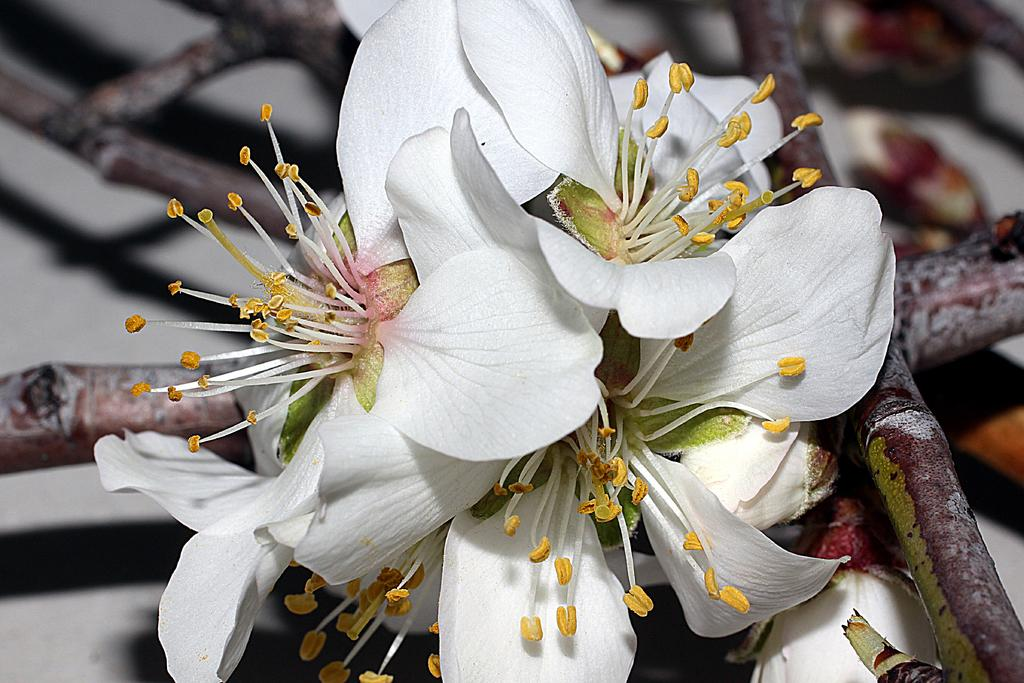What type of flowers can be seen in the image? There are white-colored flowers in the image. What type of lunch is being prepared in the image? There is no indication of any lunch preparation in the image, as it only features white-colored flowers. 